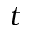<formula> <loc_0><loc_0><loc_500><loc_500>t</formula> 